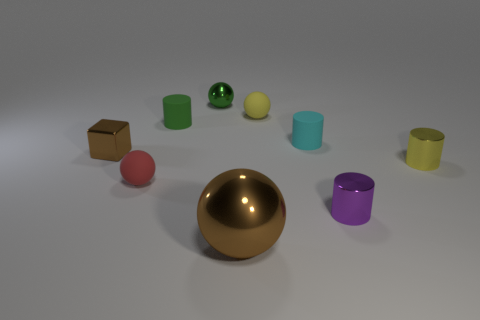Subtract all yellow spheres. How many spheres are left? 3 Subtract 2 spheres. How many spheres are left? 2 Subtract all green cylinders. How many cylinders are left? 3 Add 1 red matte cubes. How many objects exist? 10 Subtract all purple balls. Subtract all green cylinders. How many balls are left? 4 Subtract all blocks. How many objects are left? 8 Add 6 tiny yellow shiny cylinders. How many tiny yellow shiny cylinders exist? 7 Subtract 1 red balls. How many objects are left? 8 Subtract all tiny rubber cylinders. Subtract all yellow spheres. How many objects are left? 6 Add 3 tiny green matte objects. How many tiny green matte objects are left? 4 